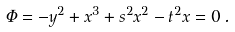Convert formula to latex. <formula><loc_0><loc_0><loc_500><loc_500>\Phi = - y ^ { 2 } + x ^ { 3 } + s ^ { 2 } x ^ { 2 } - t ^ { 2 } x = 0 \, .</formula> 